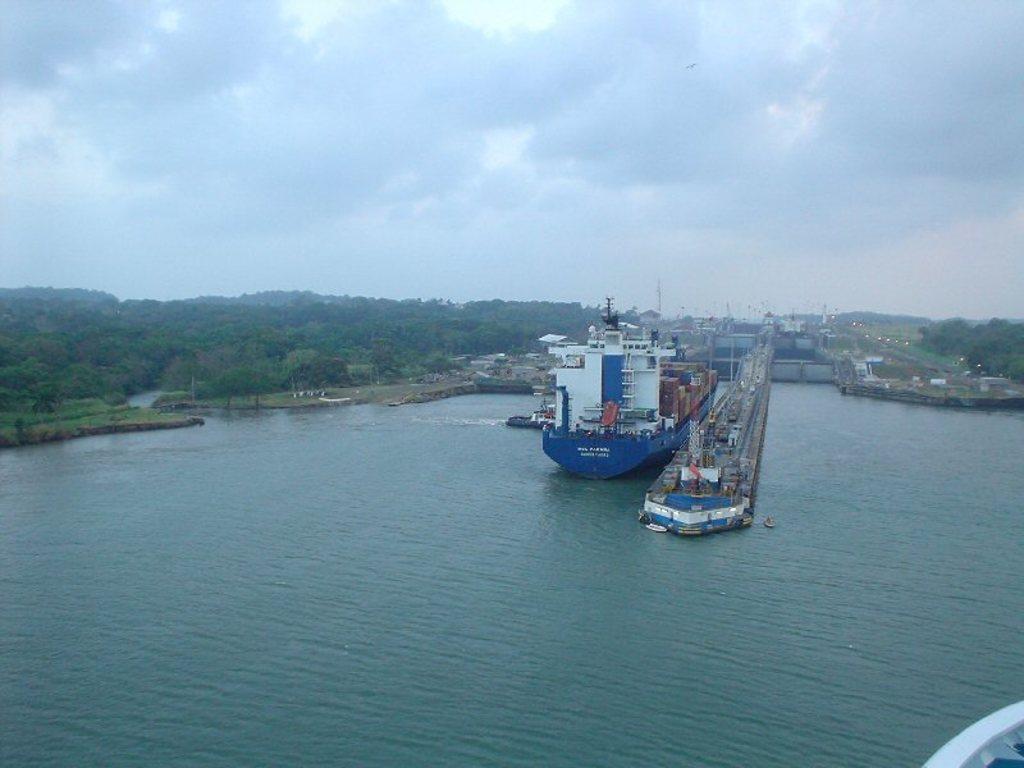Could you give a brief overview of what you see in this image? In this image I can see a ship on the water, the ship is in blue and white color. I can also see a bridge, background I can see trees in green color and the sky is in white and gray color. 